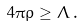<formula> <loc_0><loc_0><loc_500><loc_500>4 \pi \rho \geq \Lambda \, .</formula> 